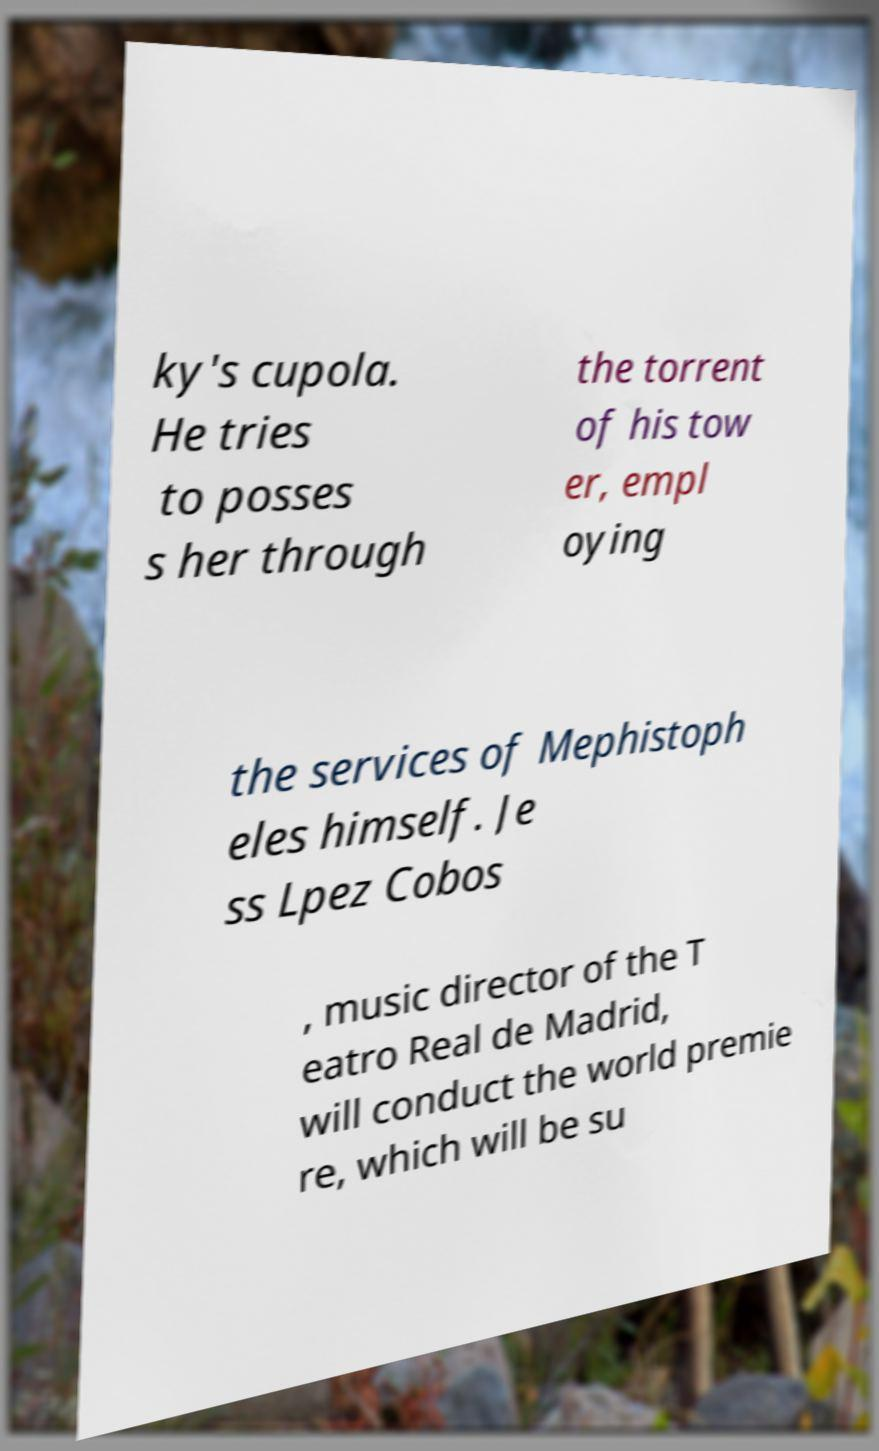What messages or text are displayed in this image? I need them in a readable, typed format. ky's cupola. He tries to posses s her through the torrent of his tow er, empl oying the services of Mephistoph eles himself. Je ss Lpez Cobos , music director of the T eatro Real de Madrid, will conduct the world premie re, which will be su 